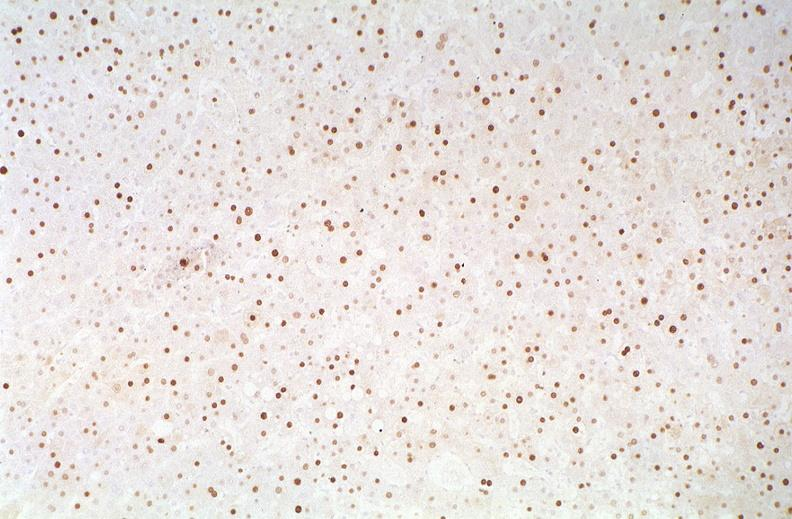what is present?
Answer the question using a single word or phrase. Hepatobiliary 